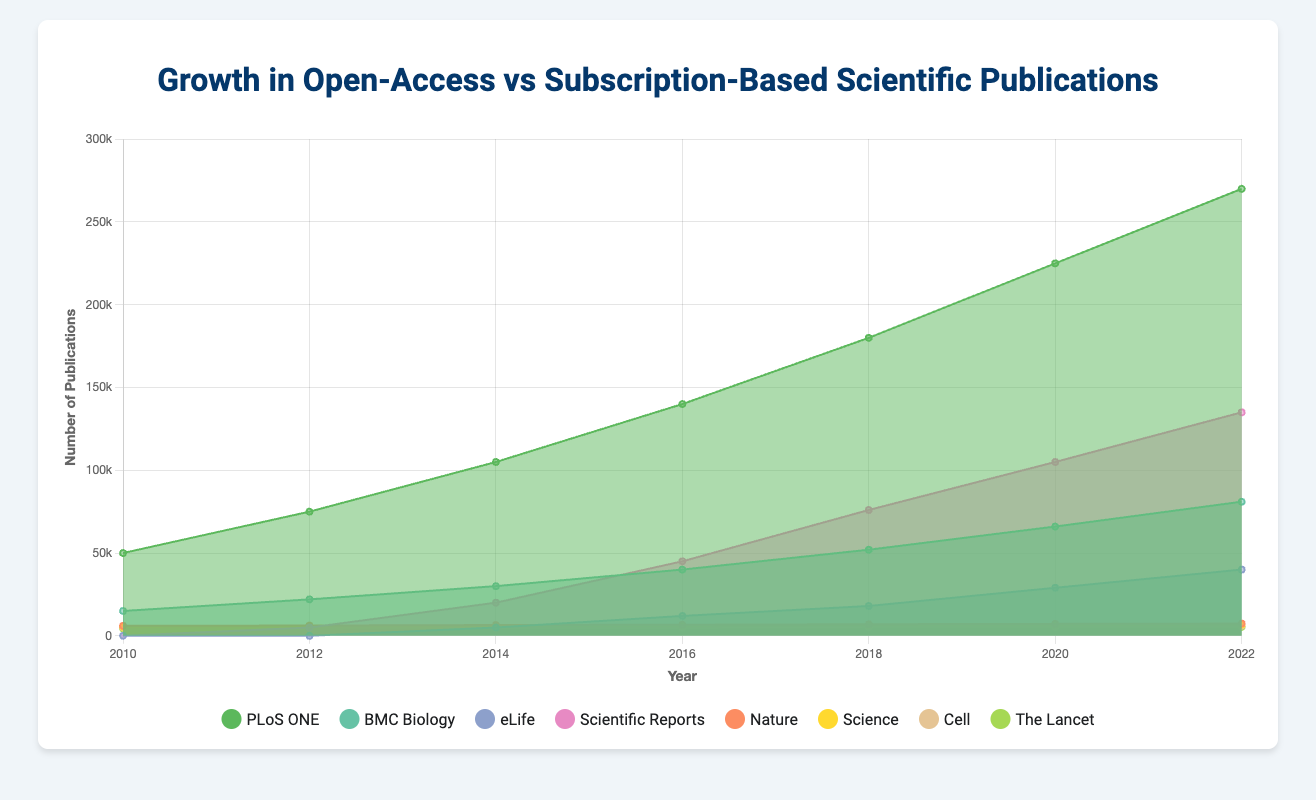What's the title of the chart? The title of the chart is displayed at the top, usually in a larger or bold font, indicating the main topic of the visualization.
Answer: Growth in Open-Access vs Subscription-Based Scientific Publications Which journal had the highest number of publications in 2022? To determine the journal with the highest publications in 2022, look at the values for each journal in that year and identify the highest one.
Answer: PLoS ONE How does the growth of Scientific Reports compare to Nature from 2012 to 2022? Calculate the difference in publications from 2012 to 2022 for both journals and compare the values. Scientific Reports: 135000 - 5000 = 130000; Nature: 7400 - 6200 = 1200.
Answer: Scientific Reports grew 130000, while Nature grew 1200 Between which years did PLoS ONE see the highest growth in the number of publications? Calculate the growth between each pair of consecutive years by subtracting the previous year's value from the current year's value, and then identify the pair with the highest difference.
Answer: 2014 to 2016 (35000 publications) What was the total number of open-access publications in 2020? Sum the values for all open-access journals for the year 2020. PLoS ONE: 225000, BMC Biology: 66000, eLife: 29000, Scientific Reports: 105000. Total = 225000 + 66000 + 29000 + 105000 = 425000.
Answer: 425000 Which journal showed the most consistent number of publications over the years? Identify the journal with the least variation in the number of publications over the years by examining the data points for each journal.
Answer: Nature What is the average number of publications for Science in the given years? Sum the number of publications for Science for all the years and then divide by the number of data points (7 years). Total = 5500 + 5700 + 5900 + 6100 + 6400 + 6600 + 6800 = 43000. Average = 43000 / 7 = 6142.86.
Answer: 6142.86 By how much did BMC Biology's publications increase from 2010 to 2018? Subtract the number of publications in 2010 from the number in 2018. 52000 - 15000 = 37000.
Answer: 37000 Which journal started publishing after 2010? Identify the journal that has a value of zero for the year 2010 and non-zero values in subsequent years.
Answer: eLife and Scientific Reports 